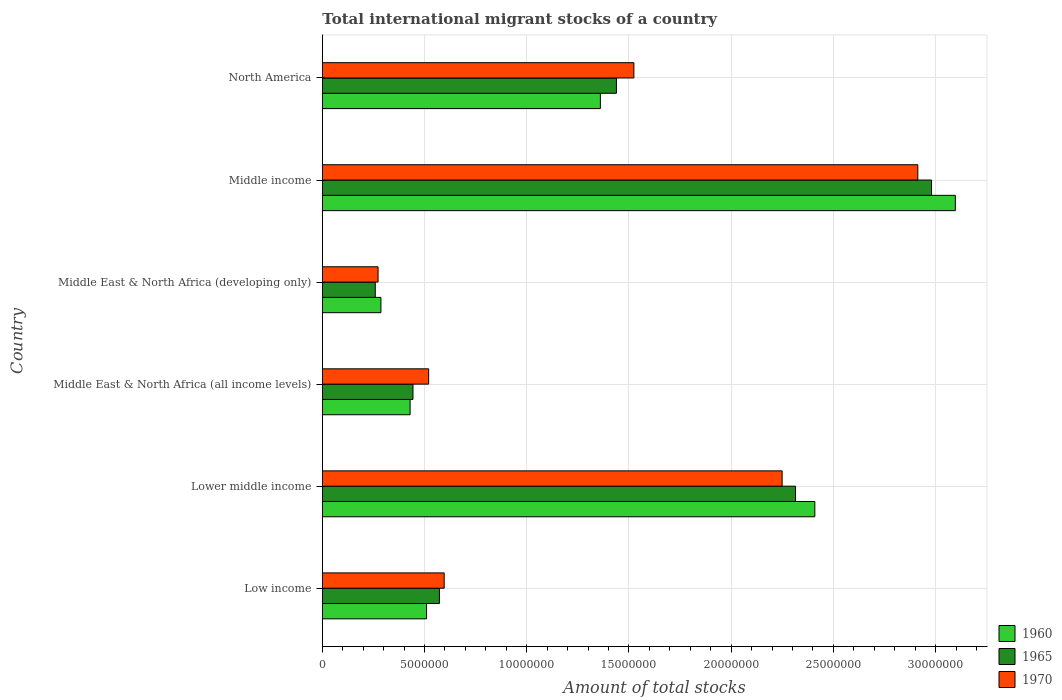How many different coloured bars are there?
Your answer should be compact. 3. Are the number of bars on each tick of the Y-axis equal?
Provide a short and direct response. Yes. What is the label of the 6th group of bars from the top?
Make the answer very short. Low income. In how many cases, is the number of bars for a given country not equal to the number of legend labels?
Ensure brevity in your answer.  0. What is the amount of total stocks in in 1965 in North America?
Make the answer very short. 1.44e+07. Across all countries, what is the maximum amount of total stocks in in 1970?
Provide a succinct answer. 2.91e+07. Across all countries, what is the minimum amount of total stocks in in 1970?
Make the answer very short. 2.73e+06. In which country was the amount of total stocks in in 1960 minimum?
Offer a terse response. Middle East & North Africa (developing only). What is the total amount of total stocks in in 1970 in the graph?
Offer a very short reply. 8.07e+07. What is the difference between the amount of total stocks in in 1960 in Lower middle income and that in Middle East & North Africa (all income levels)?
Keep it short and to the point. 1.98e+07. What is the difference between the amount of total stocks in in 1970 in Middle income and the amount of total stocks in in 1965 in Lower middle income?
Your answer should be very brief. 5.98e+06. What is the average amount of total stocks in in 1970 per country?
Provide a short and direct response. 1.35e+07. What is the difference between the amount of total stocks in in 1965 and amount of total stocks in in 1970 in Middle East & North Africa (developing only)?
Keep it short and to the point. -1.37e+05. What is the ratio of the amount of total stocks in in 1960 in Middle East & North Africa (all income levels) to that in North America?
Provide a short and direct response. 0.32. Is the amount of total stocks in in 1965 in Low income less than that in Middle East & North Africa (all income levels)?
Your answer should be compact. No. What is the difference between the highest and the second highest amount of total stocks in in 1970?
Your answer should be very brief. 6.64e+06. What is the difference between the highest and the lowest amount of total stocks in in 1970?
Make the answer very short. 2.64e+07. In how many countries, is the amount of total stocks in in 1960 greater than the average amount of total stocks in in 1960 taken over all countries?
Make the answer very short. 3. Is the sum of the amount of total stocks in in 1970 in Lower middle income and North America greater than the maximum amount of total stocks in in 1960 across all countries?
Make the answer very short. Yes. What does the 2nd bar from the bottom in Middle East & North Africa (all income levels) represents?
Make the answer very short. 1965. Is it the case that in every country, the sum of the amount of total stocks in in 1970 and amount of total stocks in in 1960 is greater than the amount of total stocks in in 1965?
Provide a short and direct response. Yes. Are all the bars in the graph horizontal?
Keep it short and to the point. Yes. How many countries are there in the graph?
Ensure brevity in your answer.  6. What is the difference between two consecutive major ticks on the X-axis?
Ensure brevity in your answer.  5.00e+06. Does the graph contain any zero values?
Provide a short and direct response. No. Does the graph contain grids?
Your response must be concise. Yes. How many legend labels are there?
Your answer should be compact. 3. How are the legend labels stacked?
Give a very brief answer. Vertical. What is the title of the graph?
Offer a terse response. Total international migrant stocks of a country. What is the label or title of the X-axis?
Offer a terse response. Amount of total stocks. What is the Amount of total stocks of 1960 in Low income?
Make the answer very short. 5.10e+06. What is the Amount of total stocks in 1965 in Low income?
Offer a terse response. 5.73e+06. What is the Amount of total stocks of 1970 in Low income?
Your answer should be very brief. 5.96e+06. What is the Amount of total stocks in 1960 in Lower middle income?
Offer a terse response. 2.41e+07. What is the Amount of total stocks in 1965 in Lower middle income?
Ensure brevity in your answer.  2.31e+07. What is the Amount of total stocks of 1970 in Lower middle income?
Offer a terse response. 2.25e+07. What is the Amount of total stocks in 1960 in Middle East & North Africa (all income levels)?
Your response must be concise. 4.29e+06. What is the Amount of total stocks of 1965 in Middle East & North Africa (all income levels)?
Your answer should be compact. 4.43e+06. What is the Amount of total stocks in 1970 in Middle East & North Africa (all income levels)?
Your answer should be compact. 5.20e+06. What is the Amount of total stocks of 1960 in Middle East & North Africa (developing only)?
Keep it short and to the point. 2.87e+06. What is the Amount of total stocks in 1965 in Middle East & North Africa (developing only)?
Your response must be concise. 2.59e+06. What is the Amount of total stocks of 1970 in Middle East & North Africa (developing only)?
Provide a succinct answer. 2.73e+06. What is the Amount of total stocks of 1960 in Middle income?
Give a very brief answer. 3.10e+07. What is the Amount of total stocks in 1965 in Middle income?
Make the answer very short. 2.98e+07. What is the Amount of total stocks in 1970 in Middle income?
Make the answer very short. 2.91e+07. What is the Amount of total stocks of 1960 in North America?
Provide a succinct answer. 1.36e+07. What is the Amount of total stocks in 1965 in North America?
Offer a terse response. 1.44e+07. What is the Amount of total stocks in 1970 in North America?
Ensure brevity in your answer.  1.52e+07. Across all countries, what is the maximum Amount of total stocks of 1960?
Keep it short and to the point. 3.10e+07. Across all countries, what is the maximum Amount of total stocks in 1965?
Ensure brevity in your answer.  2.98e+07. Across all countries, what is the maximum Amount of total stocks of 1970?
Your response must be concise. 2.91e+07. Across all countries, what is the minimum Amount of total stocks of 1960?
Provide a short and direct response. 2.87e+06. Across all countries, what is the minimum Amount of total stocks in 1965?
Your answer should be very brief. 2.59e+06. Across all countries, what is the minimum Amount of total stocks of 1970?
Offer a terse response. 2.73e+06. What is the total Amount of total stocks of 1960 in the graph?
Make the answer very short. 8.09e+07. What is the total Amount of total stocks of 1965 in the graph?
Provide a short and direct response. 8.01e+07. What is the total Amount of total stocks in 1970 in the graph?
Make the answer very short. 8.07e+07. What is the difference between the Amount of total stocks of 1960 in Low income and that in Lower middle income?
Ensure brevity in your answer.  -1.90e+07. What is the difference between the Amount of total stocks in 1965 in Low income and that in Lower middle income?
Provide a short and direct response. -1.74e+07. What is the difference between the Amount of total stocks in 1970 in Low income and that in Lower middle income?
Ensure brevity in your answer.  -1.65e+07. What is the difference between the Amount of total stocks of 1960 in Low income and that in Middle East & North Africa (all income levels)?
Keep it short and to the point. 8.04e+05. What is the difference between the Amount of total stocks of 1965 in Low income and that in Middle East & North Africa (all income levels)?
Your answer should be very brief. 1.29e+06. What is the difference between the Amount of total stocks in 1970 in Low income and that in Middle East & North Africa (all income levels)?
Your answer should be very brief. 7.60e+05. What is the difference between the Amount of total stocks of 1960 in Low income and that in Middle East & North Africa (developing only)?
Provide a short and direct response. 2.23e+06. What is the difference between the Amount of total stocks in 1965 in Low income and that in Middle East & North Africa (developing only)?
Ensure brevity in your answer.  3.14e+06. What is the difference between the Amount of total stocks of 1970 in Low income and that in Middle East & North Africa (developing only)?
Provide a succinct answer. 3.23e+06. What is the difference between the Amount of total stocks in 1960 in Low income and that in Middle income?
Provide a succinct answer. -2.59e+07. What is the difference between the Amount of total stocks of 1965 in Low income and that in Middle income?
Offer a terse response. -2.41e+07. What is the difference between the Amount of total stocks of 1970 in Low income and that in Middle income?
Offer a terse response. -2.32e+07. What is the difference between the Amount of total stocks in 1960 in Low income and that in North America?
Offer a very short reply. -8.50e+06. What is the difference between the Amount of total stocks of 1965 in Low income and that in North America?
Keep it short and to the point. -8.66e+06. What is the difference between the Amount of total stocks of 1970 in Low income and that in North America?
Offer a terse response. -9.28e+06. What is the difference between the Amount of total stocks of 1960 in Lower middle income and that in Middle East & North Africa (all income levels)?
Your response must be concise. 1.98e+07. What is the difference between the Amount of total stocks in 1965 in Lower middle income and that in Middle East & North Africa (all income levels)?
Give a very brief answer. 1.87e+07. What is the difference between the Amount of total stocks in 1970 in Lower middle income and that in Middle East & North Africa (all income levels)?
Offer a terse response. 1.73e+07. What is the difference between the Amount of total stocks in 1960 in Lower middle income and that in Middle East & North Africa (developing only)?
Provide a short and direct response. 2.12e+07. What is the difference between the Amount of total stocks in 1965 in Lower middle income and that in Middle East & North Africa (developing only)?
Provide a short and direct response. 2.06e+07. What is the difference between the Amount of total stocks in 1970 in Lower middle income and that in Middle East & North Africa (developing only)?
Make the answer very short. 1.98e+07. What is the difference between the Amount of total stocks of 1960 in Lower middle income and that in Middle income?
Give a very brief answer. -6.87e+06. What is the difference between the Amount of total stocks of 1965 in Lower middle income and that in Middle income?
Offer a very short reply. -6.65e+06. What is the difference between the Amount of total stocks in 1970 in Lower middle income and that in Middle income?
Provide a succinct answer. -6.64e+06. What is the difference between the Amount of total stocks of 1960 in Lower middle income and that in North America?
Offer a terse response. 1.05e+07. What is the difference between the Amount of total stocks of 1965 in Lower middle income and that in North America?
Offer a terse response. 8.76e+06. What is the difference between the Amount of total stocks of 1970 in Lower middle income and that in North America?
Offer a very short reply. 7.25e+06. What is the difference between the Amount of total stocks in 1960 in Middle East & North Africa (all income levels) and that in Middle East & North Africa (developing only)?
Ensure brevity in your answer.  1.43e+06. What is the difference between the Amount of total stocks of 1965 in Middle East & North Africa (all income levels) and that in Middle East & North Africa (developing only)?
Make the answer very short. 1.84e+06. What is the difference between the Amount of total stocks of 1970 in Middle East & North Africa (all income levels) and that in Middle East & North Africa (developing only)?
Give a very brief answer. 2.47e+06. What is the difference between the Amount of total stocks in 1960 in Middle East & North Africa (all income levels) and that in Middle income?
Your answer should be compact. -2.67e+07. What is the difference between the Amount of total stocks of 1965 in Middle East & North Africa (all income levels) and that in Middle income?
Keep it short and to the point. -2.54e+07. What is the difference between the Amount of total stocks of 1970 in Middle East & North Africa (all income levels) and that in Middle income?
Offer a very short reply. -2.39e+07. What is the difference between the Amount of total stocks of 1960 in Middle East & North Africa (all income levels) and that in North America?
Your response must be concise. -9.31e+06. What is the difference between the Amount of total stocks in 1965 in Middle East & North Africa (all income levels) and that in North America?
Give a very brief answer. -9.95e+06. What is the difference between the Amount of total stocks in 1970 in Middle East & North Africa (all income levels) and that in North America?
Keep it short and to the point. -1.00e+07. What is the difference between the Amount of total stocks of 1960 in Middle East & North Africa (developing only) and that in Middle income?
Offer a terse response. -2.81e+07. What is the difference between the Amount of total stocks in 1965 in Middle East & North Africa (developing only) and that in Middle income?
Provide a short and direct response. -2.72e+07. What is the difference between the Amount of total stocks of 1970 in Middle East & North Africa (developing only) and that in Middle income?
Offer a very short reply. -2.64e+07. What is the difference between the Amount of total stocks in 1960 in Middle East & North Africa (developing only) and that in North America?
Give a very brief answer. -1.07e+07. What is the difference between the Amount of total stocks in 1965 in Middle East & North Africa (developing only) and that in North America?
Offer a very short reply. -1.18e+07. What is the difference between the Amount of total stocks of 1970 in Middle East & North Africa (developing only) and that in North America?
Your answer should be very brief. -1.25e+07. What is the difference between the Amount of total stocks of 1960 in Middle income and that in North America?
Your answer should be compact. 1.74e+07. What is the difference between the Amount of total stocks of 1965 in Middle income and that in North America?
Provide a short and direct response. 1.54e+07. What is the difference between the Amount of total stocks of 1970 in Middle income and that in North America?
Ensure brevity in your answer.  1.39e+07. What is the difference between the Amount of total stocks in 1960 in Low income and the Amount of total stocks in 1965 in Lower middle income?
Give a very brief answer. -1.80e+07. What is the difference between the Amount of total stocks of 1960 in Low income and the Amount of total stocks of 1970 in Lower middle income?
Give a very brief answer. -1.74e+07. What is the difference between the Amount of total stocks of 1965 in Low income and the Amount of total stocks of 1970 in Lower middle income?
Your answer should be very brief. -1.68e+07. What is the difference between the Amount of total stocks of 1960 in Low income and the Amount of total stocks of 1965 in Middle East & North Africa (all income levels)?
Give a very brief answer. 6.64e+05. What is the difference between the Amount of total stocks in 1960 in Low income and the Amount of total stocks in 1970 in Middle East & North Africa (all income levels)?
Your response must be concise. -1.03e+05. What is the difference between the Amount of total stocks of 1965 in Low income and the Amount of total stocks of 1970 in Middle East & North Africa (all income levels)?
Your answer should be very brief. 5.27e+05. What is the difference between the Amount of total stocks of 1960 in Low income and the Amount of total stocks of 1965 in Middle East & North Africa (developing only)?
Ensure brevity in your answer.  2.51e+06. What is the difference between the Amount of total stocks of 1960 in Low income and the Amount of total stocks of 1970 in Middle East & North Africa (developing only)?
Your answer should be compact. 2.37e+06. What is the difference between the Amount of total stocks in 1965 in Low income and the Amount of total stocks in 1970 in Middle East & North Africa (developing only)?
Make the answer very short. 3.00e+06. What is the difference between the Amount of total stocks of 1960 in Low income and the Amount of total stocks of 1965 in Middle income?
Provide a short and direct response. -2.47e+07. What is the difference between the Amount of total stocks in 1960 in Low income and the Amount of total stocks in 1970 in Middle income?
Ensure brevity in your answer.  -2.40e+07. What is the difference between the Amount of total stocks in 1965 in Low income and the Amount of total stocks in 1970 in Middle income?
Your response must be concise. -2.34e+07. What is the difference between the Amount of total stocks of 1960 in Low income and the Amount of total stocks of 1965 in North America?
Offer a very short reply. -9.29e+06. What is the difference between the Amount of total stocks of 1960 in Low income and the Amount of total stocks of 1970 in North America?
Keep it short and to the point. -1.01e+07. What is the difference between the Amount of total stocks of 1965 in Low income and the Amount of total stocks of 1970 in North America?
Provide a short and direct response. -9.51e+06. What is the difference between the Amount of total stocks of 1960 in Lower middle income and the Amount of total stocks of 1965 in Middle East & North Africa (all income levels)?
Provide a short and direct response. 1.97e+07. What is the difference between the Amount of total stocks of 1960 in Lower middle income and the Amount of total stocks of 1970 in Middle East & North Africa (all income levels)?
Give a very brief answer. 1.89e+07. What is the difference between the Amount of total stocks in 1965 in Lower middle income and the Amount of total stocks in 1970 in Middle East & North Africa (all income levels)?
Make the answer very short. 1.79e+07. What is the difference between the Amount of total stocks of 1960 in Lower middle income and the Amount of total stocks of 1965 in Middle East & North Africa (developing only)?
Keep it short and to the point. 2.15e+07. What is the difference between the Amount of total stocks of 1960 in Lower middle income and the Amount of total stocks of 1970 in Middle East & North Africa (developing only)?
Keep it short and to the point. 2.14e+07. What is the difference between the Amount of total stocks in 1965 in Lower middle income and the Amount of total stocks in 1970 in Middle East & North Africa (developing only)?
Make the answer very short. 2.04e+07. What is the difference between the Amount of total stocks in 1960 in Lower middle income and the Amount of total stocks in 1965 in Middle income?
Offer a very short reply. -5.71e+06. What is the difference between the Amount of total stocks of 1960 in Lower middle income and the Amount of total stocks of 1970 in Middle income?
Your response must be concise. -5.04e+06. What is the difference between the Amount of total stocks of 1965 in Lower middle income and the Amount of total stocks of 1970 in Middle income?
Make the answer very short. -5.98e+06. What is the difference between the Amount of total stocks of 1960 in Lower middle income and the Amount of total stocks of 1965 in North America?
Offer a very short reply. 9.70e+06. What is the difference between the Amount of total stocks of 1960 in Lower middle income and the Amount of total stocks of 1970 in North America?
Ensure brevity in your answer.  8.85e+06. What is the difference between the Amount of total stocks in 1965 in Lower middle income and the Amount of total stocks in 1970 in North America?
Offer a terse response. 7.91e+06. What is the difference between the Amount of total stocks of 1960 in Middle East & North Africa (all income levels) and the Amount of total stocks of 1965 in Middle East & North Africa (developing only)?
Keep it short and to the point. 1.70e+06. What is the difference between the Amount of total stocks of 1960 in Middle East & North Africa (all income levels) and the Amount of total stocks of 1970 in Middle East & North Africa (developing only)?
Offer a very short reply. 1.57e+06. What is the difference between the Amount of total stocks of 1965 in Middle East & North Africa (all income levels) and the Amount of total stocks of 1970 in Middle East & North Africa (developing only)?
Your response must be concise. 1.71e+06. What is the difference between the Amount of total stocks of 1960 in Middle East & North Africa (all income levels) and the Amount of total stocks of 1965 in Middle income?
Your response must be concise. -2.55e+07. What is the difference between the Amount of total stocks in 1960 in Middle East & North Africa (all income levels) and the Amount of total stocks in 1970 in Middle income?
Your response must be concise. -2.48e+07. What is the difference between the Amount of total stocks in 1965 in Middle East & North Africa (all income levels) and the Amount of total stocks in 1970 in Middle income?
Your answer should be very brief. -2.47e+07. What is the difference between the Amount of total stocks of 1960 in Middle East & North Africa (all income levels) and the Amount of total stocks of 1965 in North America?
Offer a terse response. -1.01e+07. What is the difference between the Amount of total stocks of 1960 in Middle East & North Africa (all income levels) and the Amount of total stocks of 1970 in North America?
Make the answer very short. -1.09e+07. What is the difference between the Amount of total stocks in 1965 in Middle East & North Africa (all income levels) and the Amount of total stocks in 1970 in North America?
Offer a terse response. -1.08e+07. What is the difference between the Amount of total stocks of 1960 in Middle East & North Africa (developing only) and the Amount of total stocks of 1965 in Middle income?
Ensure brevity in your answer.  -2.69e+07. What is the difference between the Amount of total stocks of 1960 in Middle East & North Africa (developing only) and the Amount of total stocks of 1970 in Middle income?
Give a very brief answer. -2.63e+07. What is the difference between the Amount of total stocks of 1965 in Middle East & North Africa (developing only) and the Amount of total stocks of 1970 in Middle income?
Provide a succinct answer. -2.65e+07. What is the difference between the Amount of total stocks of 1960 in Middle East & North Africa (developing only) and the Amount of total stocks of 1965 in North America?
Make the answer very short. -1.15e+07. What is the difference between the Amount of total stocks in 1960 in Middle East & North Africa (developing only) and the Amount of total stocks in 1970 in North America?
Your response must be concise. -1.24e+07. What is the difference between the Amount of total stocks of 1965 in Middle East & North Africa (developing only) and the Amount of total stocks of 1970 in North America?
Provide a succinct answer. -1.26e+07. What is the difference between the Amount of total stocks of 1960 in Middle income and the Amount of total stocks of 1965 in North America?
Your response must be concise. 1.66e+07. What is the difference between the Amount of total stocks of 1960 in Middle income and the Amount of total stocks of 1970 in North America?
Give a very brief answer. 1.57e+07. What is the difference between the Amount of total stocks in 1965 in Middle income and the Amount of total stocks in 1970 in North America?
Ensure brevity in your answer.  1.46e+07. What is the average Amount of total stocks of 1960 per country?
Your answer should be compact. 1.35e+07. What is the average Amount of total stocks in 1965 per country?
Your answer should be compact. 1.33e+07. What is the average Amount of total stocks in 1970 per country?
Offer a very short reply. 1.35e+07. What is the difference between the Amount of total stocks of 1960 and Amount of total stocks of 1965 in Low income?
Your response must be concise. -6.30e+05. What is the difference between the Amount of total stocks of 1960 and Amount of total stocks of 1970 in Low income?
Your answer should be very brief. -8.63e+05. What is the difference between the Amount of total stocks of 1965 and Amount of total stocks of 1970 in Low income?
Ensure brevity in your answer.  -2.33e+05. What is the difference between the Amount of total stocks of 1960 and Amount of total stocks of 1965 in Lower middle income?
Your response must be concise. 9.46e+05. What is the difference between the Amount of total stocks of 1960 and Amount of total stocks of 1970 in Lower middle income?
Give a very brief answer. 1.60e+06. What is the difference between the Amount of total stocks in 1965 and Amount of total stocks in 1970 in Lower middle income?
Your answer should be compact. 6.54e+05. What is the difference between the Amount of total stocks in 1960 and Amount of total stocks in 1965 in Middle East & North Africa (all income levels)?
Give a very brief answer. -1.41e+05. What is the difference between the Amount of total stocks of 1960 and Amount of total stocks of 1970 in Middle East & North Africa (all income levels)?
Provide a succinct answer. -9.07e+05. What is the difference between the Amount of total stocks of 1965 and Amount of total stocks of 1970 in Middle East & North Africa (all income levels)?
Give a very brief answer. -7.67e+05. What is the difference between the Amount of total stocks of 1960 and Amount of total stocks of 1965 in Middle East & North Africa (developing only)?
Make the answer very short. 2.76e+05. What is the difference between the Amount of total stocks of 1960 and Amount of total stocks of 1970 in Middle East & North Africa (developing only)?
Provide a succinct answer. 1.39e+05. What is the difference between the Amount of total stocks of 1965 and Amount of total stocks of 1970 in Middle East & North Africa (developing only)?
Offer a terse response. -1.37e+05. What is the difference between the Amount of total stocks of 1960 and Amount of total stocks of 1965 in Middle income?
Your answer should be compact. 1.16e+06. What is the difference between the Amount of total stocks in 1960 and Amount of total stocks in 1970 in Middle income?
Give a very brief answer. 1.84e+06. What is the difference between the Amount of total stocks in 1965 and Amount of total stocks in 1970 in Middle income?
Ensure brevity in your answer.  6.71e+05. What is the difference between the Amount of total stocks of 1960 and Amount of total stocks of 1965 in North America?
Provide a short and direct response. -7.85e+05. What is the difference between the Amount of total stocks of 1960 and Amount of total stocks of 1970 in North America?
Keep it short and to the point. -1.64e+06. What is the difference between the Amount of total stocks in 1965 and Amount of total stocks in 1970 in North America?
Your answer should be very brief. -8.53e+05. What is the ratio of the Amount of total stocks of 1960 in Low income to that in Lower middle income?
Ensure brevity in your answer.  0.21. What is the ratio of the Amount of total stocks of 1965 in Low income to that in Lower middle income?
Give a very brief answer. 0.25. What is the ratio of the Amount of total stocks of 1970 in Low income to that in Lower middle income?
Your answer should be very brief. 0.27. What is the ratio of the Amount of total stocks of 1960 in Low income to that in Middle East & North Africa (all income levels)?
Your answer should be compact. 1.19. What is the ratio of the Amount of total stocks of 1965 in Low income to that in Middle East & North Africa (all income levels)?
Provide a short and direct response. 1.29. What is the ratio of the Amount of total stocks in 1970 in Low income to that in Middle East & North Africa (all income levels)?
Your response must be concise. 1.15. What is the ratio of the Amount of total stocks in 1960 in Low income to that in Middle East & North Africa (developing only)?
Make the answer very short. 1.78. What is the ratio of the Amount of total stocks in 1965 in Low income to that in Middle East & North Africa (developing only)?
Give a very brief answer. 2.21. What is the ratio of the Amount of total stocks of 1970 in Low income to that in Middle East & North Africa (developing only)?
Give a very brief answer. 2.19. What is the ratio of the Amount of total stocks of 1960 in Low income to that in Middle income?
Your answer should be compact. 0.16. What is the ratio of the Amount of total stocks of 1965 in Low income to that in Middle income?
Provide a succinct answer. 0.19. What is the ratio of the Amount of total stocks in 1970 in Low income to that in Middle income?
Make the answer very short. 0.2. What is the ratio of the Amount of total stocks of 1960 in Low income to that in North America?
Keep it short and to the point. 0.37. What is the ratio of the Amount of total stocks of 1965 in Low income to that in North America?
Your answer should be compact. 0.4. What is the ratio of the Amount of total stocks in 1970 in Low income to that in North America?
Give a very brief answer. 0.39. What is the ratio of the Amount of total stocks in 1960 in Lower middle income to that in Middle East & North Africa (all income levels)?
Give a very brief answer. 5.61. What is the ratio of the Amount of total stocks of 1965 in Lower middle income to that in Middle East & North Africa (all income levels)?
Your response must be concise. 5.22. What is the ratio of the Amount of total stocks of 1970 in Lower middle income to that in Middle East & North Africa (all income levels)?
Offer a very short reply. 4.32. What is the ratio of the Amount of total stocks in 1960 in Lower middle income to that in Middle East & North Africa (developing only)?
Offer a terse response. 8.41. What is the ratio of the Amount of total stocks of 1965 in Lower middle income to that in Middle East & North Africa (developing only)?
Make the answer very short. 8.94. What is the ratio of the Amount of total stocks of 1970 in Lower middle income to that in Middle East & North Africa (developing only)?
Ensure brevity in your answer.  8.25. What is the ratio of the Amount of total stocks in 1960 in Lower middle income to that in Middle income?
Keep it short and to the point. 0.78. What is the ratio of the Amount of total stocks of 1965 in Lower middle income to that in Middle income?
Provide a succinct answer. 0.78. What is the ratio of the Amount of total stocks of 1970 in Lower middle income to that in Middle income?
Give a very brief answer. 0.77. What is the ratio of the Amount of total stocks in 1960 in Lower middle income to that in North America?
Provide a short and direct response. 1.77. What is the ratio of the Amount of total stocks in 1965 in Lower middle income to that in North America?
Give a very brief answer. 1.61. What is the ratio of the Amount of total stocks of 1970 in Lower middle income to that in North America?
Make the answer very short. 1.48. What is the ratio of the Amount of total stocks of 1960 in Middle East & North Africa (all income levels) to that in Middle East & North Africa (developing only)?
Provide a succinct answer. 1.5. What is the ratio of the Amount of total stocks in 1965 in Middle East & North Africa (all income levels) to that in Middle East & North Africa (developing only)?
Your answer should be very brief. 1.71. What is the ratio of the Amount of total stocks in 1970 in Middle East & North Africa (all income levels) to that in Middle East & North Africa (developing only)?
Offer a terse response. 1.91. What is the ratio of the Amount of total stocks of 1960 in Middle East & North Africa (all income levels) to that in Middle income?
Your answer should be compact. 0.14. What is the ratio of the Amount of total stocks in 1965 in Middle East & North Africa (all income levels) to that in Middle income?
Give a very brief answer. 0.15. What is the ratio of the Amount of total stocks of 1970 in Middle East & North Africa (all income levels) to that in Middle income?
Keep it short and to the point. 0.18. What is the ratio of the Amount of total stocks in 1960 in Middle East & North Africa (all income levels) to that in North America?
Your response must be concise. 0.32. What is the ratio of the Amount of total stocks of 1965 in Middle East & North Africa (all income levels) to that in North America?
Offer a very short reply. 0.31. What is the ratio of the Amount of total stocks of 1970 in Middle East & North Africa (all income levels) to that in North America?
Offer a very short reply. 0.34. What is the ratio of the Amount of total stocks of 1960 in Middle East & North Africa (developing only) to that in Middle income?
Keep it short and to the point. 0.09. What is the ratio of the Amount of total stocks in 1965 in Middle East & North Africa (developing only) to that in Middle income?
Your answer should be very brief. 0.09. What is the ratio of the Amount of total stocks of 1970 in Middle East & North Africa (developing only) to that in Middle income?
Ensure brevity in your answer.  0.09. What is the ratio of the Amount of total stocks in 1960 in Middle East & North Africa (developing only) to that in North America?
Your response must be concise. 0.21. What is the ratio of the Amount of total stocks in 1965 in Middle East & North Africa (developing only) to that in North America?
Your answer should be compact. 0.18. What is the ratio of the Amount of total stocks of 1970 in Middle East & North Africa (developing only) to that in North America?
Make the answer very short. 0.18. What is the ratio of the Amount of total stocks of 1960 in Middle income to that in North America?
Your answer should be very brief. 2.28. What is the ratio of the Amount of total stocks of 1965 in Middle income to that in North America?
Your answer should be compact. 2.07. What is the ratio of the Amount of total stocks of 1970 in Middle income to that in North America?
Your answer should be very brief. 1.91. What is the difference between the highest and the second highest Amount of total stocks of 1960?
Provide a succinct answer. 6.87e+06. What is the difference between the highest and the second highest Amount of total stocks in 1965?
Your answer should be very brief. 6.65e+06. What is the difference between the highest and the second highest Amount of total stocks of 1970?
Keep it short and to the point. 6.64e+06. What is the difference between the highest and the lowest Amount of total stocks in 1960?
Your response must be concise. 2.81e+07. What is the difference between the highest and the lowest Amount of total stocks of 1965?
Offer a very short reply. 2.72e+07. What is the difference between the highest and the lowest Amount of total stocks of 1970?
Offer a very short reply. 2.64e+07. 